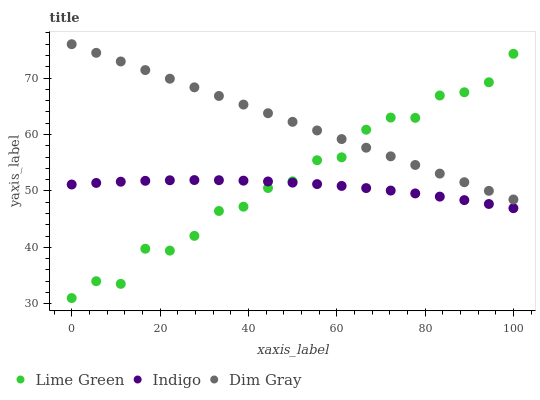Does Indigo have the minimum area under the curve?
Answer yes or no. Yes. Does Dim Gray have the maximum area under the curve?
Answer yes or no. Yes. Does Lime Green have the minimum area under the curve?
Answer yes or no. No. Does Lime Green have the maximum area under the curve?
Answer yes or no. No. Is Dim Gray the smoothest?
Answer yes or no. Yes. Is Lime Green the roughest?
Answer yes or no. Yes. Is Lime Green the smoothest?
Answer yes or no. No. Is Dim Gray the roughest?
Answer yes or no. No. Does Lime Green have the lowest value?
Answer yes or no. Yes. Does Dim Gray have the lowest value?
Answer yes or no. No. Does Dim Gray have the highest value?
Answer yes or no. Yes. Does Lime Green have the highest value?
Answer yes or no. No. Is Indigo less than Dim Gray?
Answer yes or no. Yes. Is Dim Gray greater than Indigo?
Answer yes or no. Yes. Does Dim Gray intersect Lime Green?
Answer yes or no. Yes. Is Dim Gray less than Lime Green?
Answer yes or no. No. Is Dim Gray greater than Lime Green?
Answer yes or no. No. Does Indigo intersect Dim Gray?
Answer yes or no. No. 